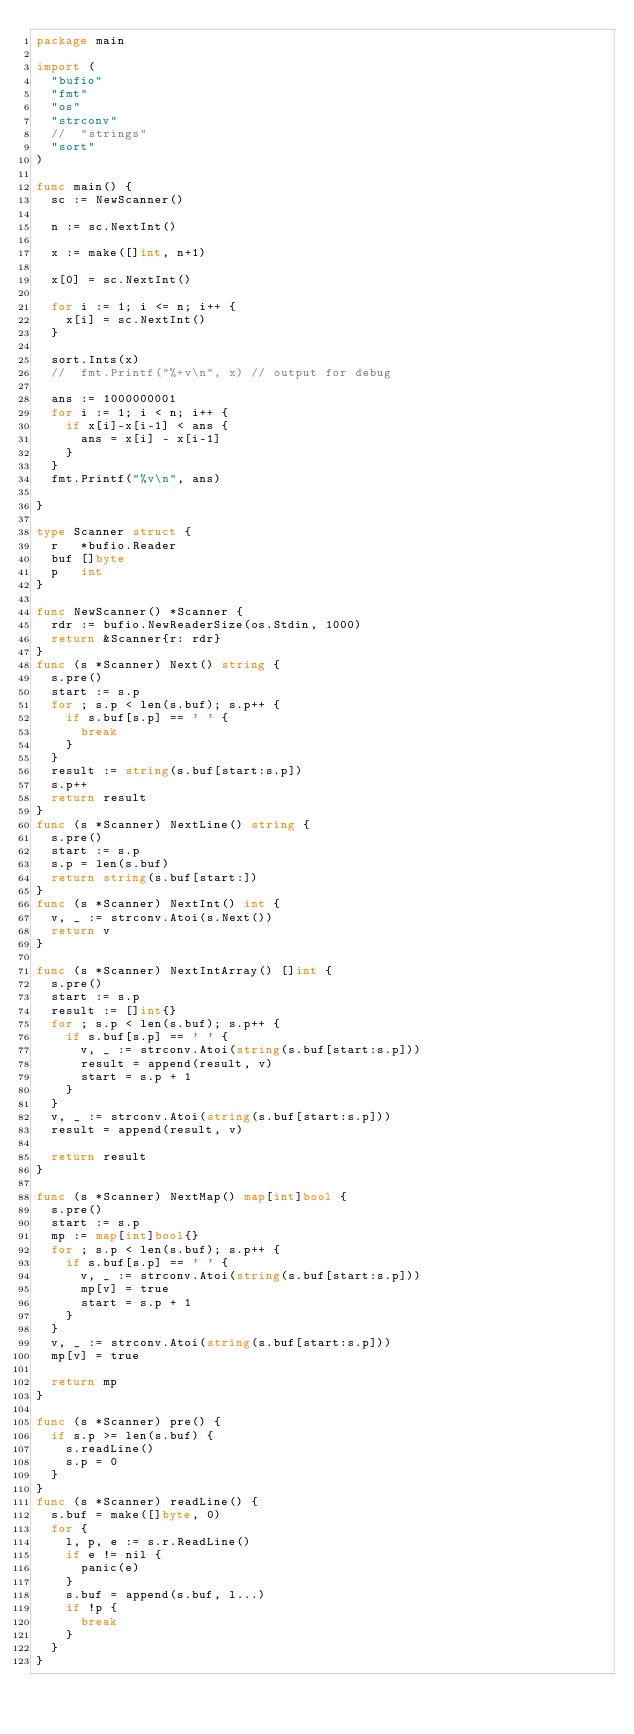<code> <loc_0><loc_0><loc_500><loc_500><_Go_>package main

import (
	"bufio"
	"fmt"
	"os"
	"strconv"
	//	"strings"
	"sort"
)

func main() {
	sc := NewScanner()

	n := sc.NextInt()

	x := make([]int, n+1)

	x[0] = sc.NextInt()

	for i := 1; i <= n; i++ {
		x[i] = sc.NextInt()
	}

	sort.Ints(x)
	//	fmt.Printf("%+v\n", x) // output for debug

	ans := 1000000001
	for i := 1; i < n; i++ {
		if x[i]-x[i-1] < ans {
			ans = x[i] - x[i-1]
		}
	}
	fmt.Printf("%v\n", ans)

}

type Scanner struct {
	r   *bufio.Reader
	buf []byte
	p   int
}

func NewScanner() *Scanner {
	rdr := bufio.NewReaderSize(os.Stdin, 1000)
	return &Scanner{r: rdr}
}
func (s *Scanner) Next() string {
	s.pre()
	start := s.p
	for ; s.p < len(s.buf); s.p++ {
		if s.buf[s.p] == ' ' {
			break
		}
	}
	result := string(s.buf[start:s.p])
	s.p++
	return result
}
func (s *Scanner) NextLine() string {
	s.pre()
	start := s.p
	s.p = len(s.buf)
	return string(s.buf[start:])
}
func (s *Scanner) NextInt() int {
	v, _ := strconv.Atoi(s.Next())
	return v
}

func (s *Scanner) NextIntArray() []int {
	s.pre()
	start := s.p
	result := []int{}
	for ; s.p < len(s.buf); s.p++ {
		if s.buf[s.p] == ' ' {
			v, _ := strconv.Atoi(string(s.buf[start:s.p]))
			result = append(result, v)
			start = s.p + 1
		}
	}
	v, _ := strconv.Atoi(string(s.buf[start:s.p]))
	result = append(result, v)

	return result
}

func (s *Scanner) NextMap() map[int]bool {
	s.pre()
	start := s.p
	mp := map[int]bool{}
	for ; s.p < len(s.buf); s.p++ {
		if s.buf[s.p] == ' ' {
			v, _ := strconv.Atoi(string(s.buf[start:s.p]))
			mp[v] = true
			start = s.p + 1
		}
	}
	v, _ := strconv.Atoi(string(s.buf[start:s.p]))
	mp[v] = true

	return mp
}

func (s *Scanner) pre() {
	if s.p >= len(s.buf) {
		s.readLine()
		s.p = 0
	}
}
func (s *Scanner) readLine() {
	s.buf = make([]byte, 0)
	for {
		l, p, e := s.r.ReadLine()
		if e != nil {
			panic(e)
		}
		s.buf = append(s.buf, l...)
		if !p {
			break
		}
	}
}
</code> 